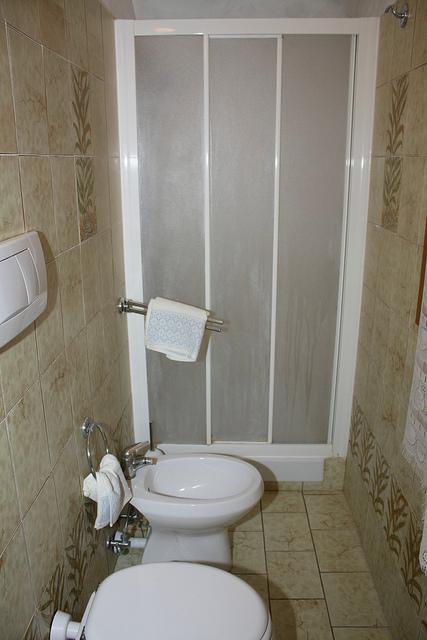How many towels are there?
Give a very brief answer. 2. How many toilets are there?
Give a very brief answer. 2. 